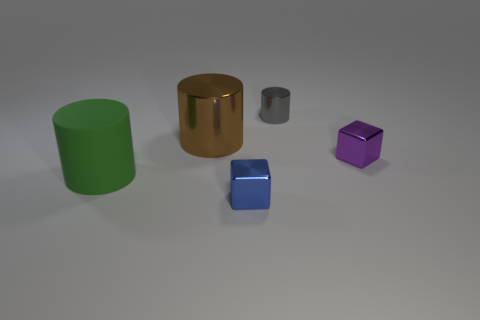How does the lighting in the scene affect the perception of the objects? The lighting in the scene comes from above, casting gentle shadows beneath each object. This overhead lighting accentuates the shapes and gives a sense of depth, highlighting the glossy surfaces of the objects and enhancing their three-dimensional appearance. Which object seems to reflect the most light? The golden cylinder reflects the most light due to its highly polished and smooth metal surface. The way it catches and reflects the light emphasizes its rounded shape and adds to its visual prominence in the scene. 